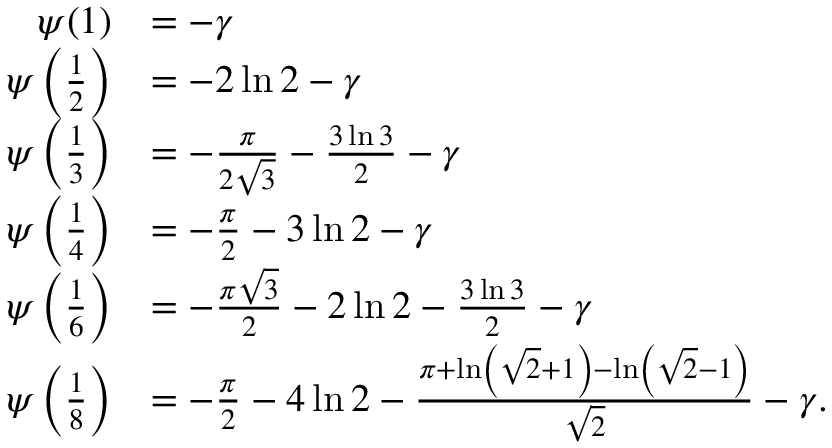Convert formula to latex. <formula><loc_0><loc_0><loc_500><loc_500>{ \begin{array} { r l } { \psi ( 1 ) } & { = - \gamma } \\ { \psi \left ( { \frac { 1 } { 2 } } \right ) } & { = - 2 \ln { 2 } - \gamma } \\ { \psi \left ( { \frac { 1 } { 3 } } \right ) } & { = - { \frac { \pi } { 2 { \sqrt { 3 } } } } - { \frac { 3 \ln { 3 } } { 2 } } - \gamma } \\ { \psi \left ( { \frac { 1 } { 4 } } \right ) } & { = - { \frac { \pi } { 2 } } - 3 \ln { 2 } - \gamma } \\ { \psi \left ( { \frac { 1 } { 6 } } \right ) } & { = - { \frac { \pi { \sqrt { 3 } } } { 2 } } - 2 \ln { 2 } - { \frac { 3 \ln { 3 } } { 2 } } - \gamma } \\ { \psi \left ( { \frac { 1 } { 8 } } \right ) } & { = - { \frac { \pi } { 2 } } - 4 \ln { 2 } - { \frac { \pi + \ln \left ( { \sqrt { 2 } } + 1 \right ) - \ln \left ( { \sqrt { 2 } } - 1 \right ) } { \sqrt { 2 } } } - \gamma . } \end{array} }</formula> 